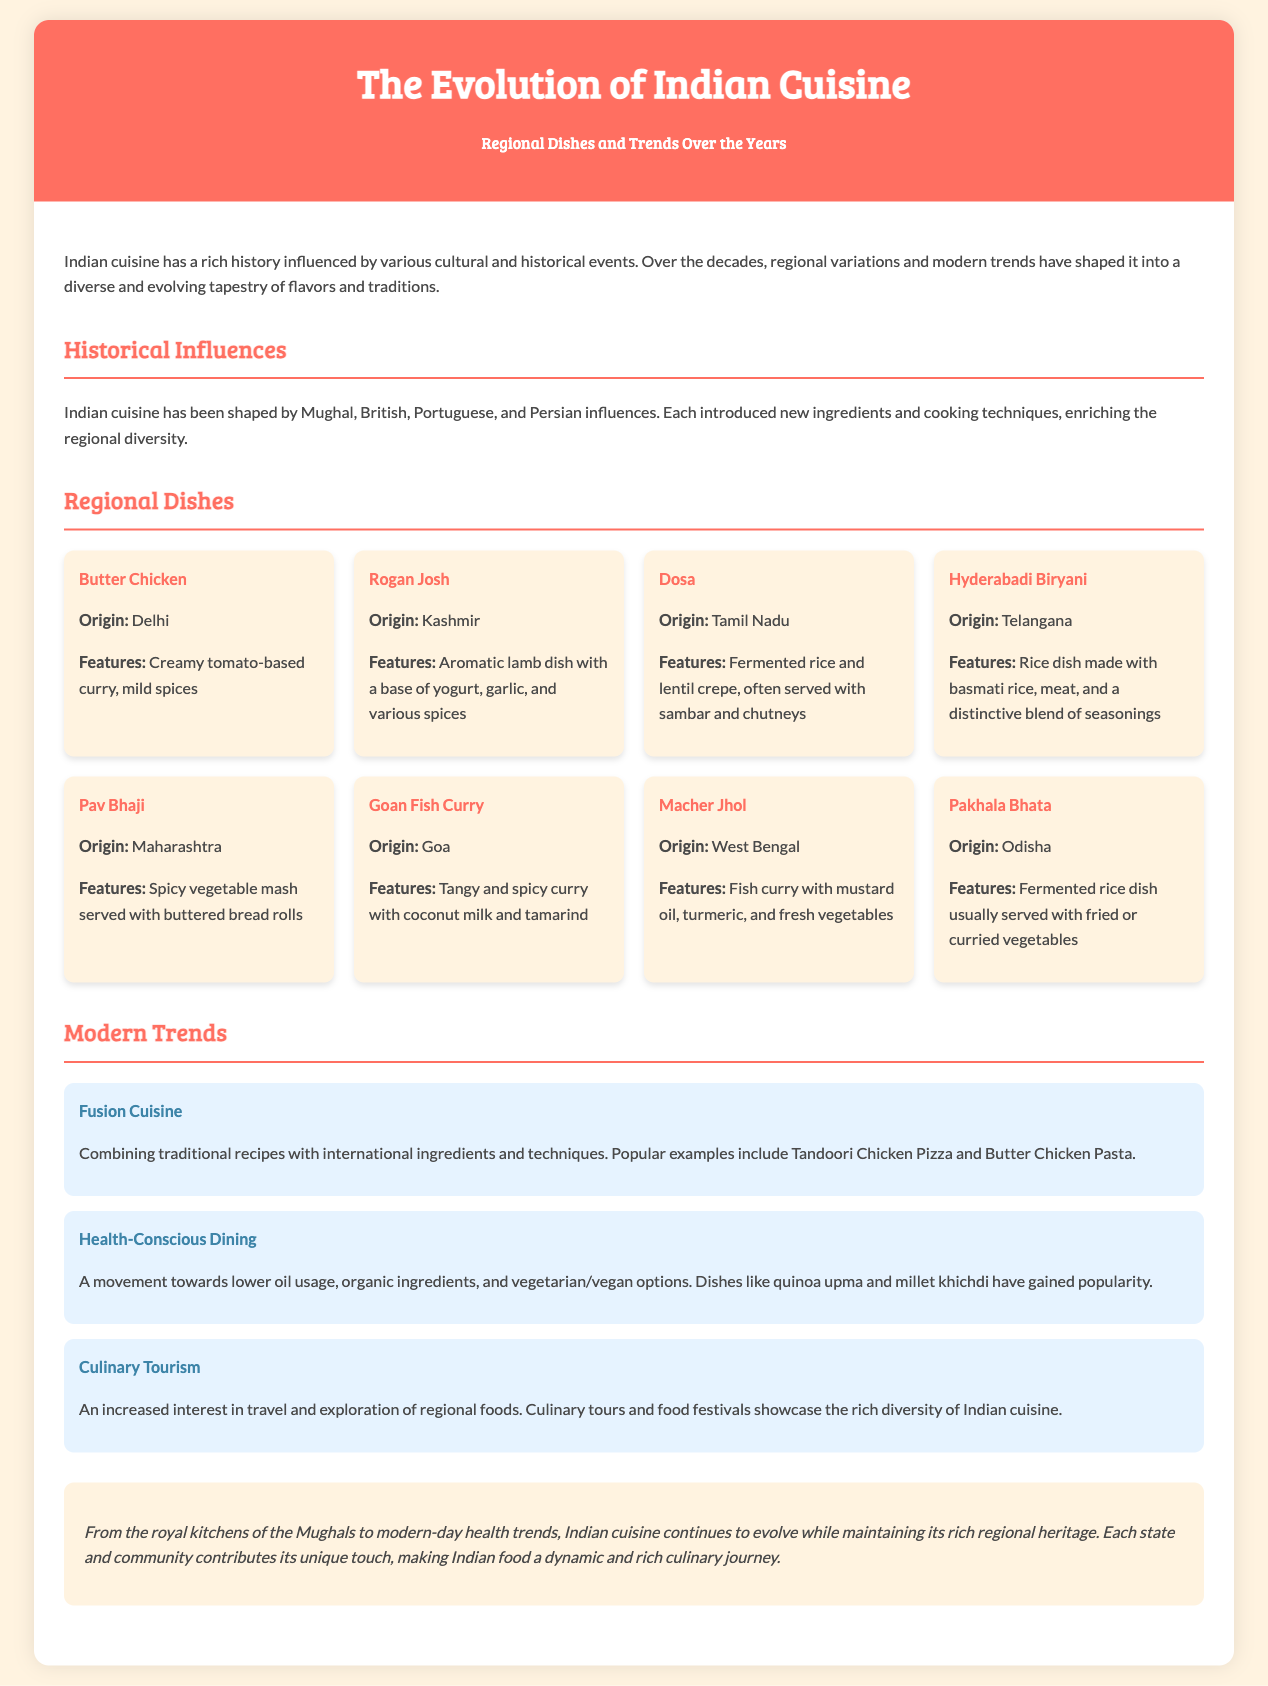what is the title of the document? The title of the document is prominently displayed at the top.
Answer: The Evolution of Indian Cuisine what are the key historical influences on Indian cuisine? The document lists the cultural influences that have shaped Indian cuisine.
Answer: Mughal, British, Portuguese, Persian which dish is associated with Delhi? The dish mentioned in the document that originates from Delhi is highlighted.
Answer: Butter Chicken what type of trend involves combining traditional recipes with international ingredients? This trend is directly mentioned under Modern Trends, indicating a culinary approach.
Answer: Fusion Cuisine which state is known for Dosa? The origin of Dosa is specified in the regional dishes section.
Answer: Tamil Nadu how many modern trends are listed? The document outlines a specific number of trends in modern Indian cuisine.
Answer: Three what flavor profile does Goan Fish Curry feature? The description in the document provides insights about the distinct taste.
Answer: Tangy and spicy which dish from Odisha involves fermented rice? The document describes a specific dish characterized by fermentation.
Answer: Pakhala Bhata what is the conclusion regarding the evolution of Indian cuisine? The final section summarizes the overarching theme of the document.
Answer: It continues to evolve while maintaining its rich regional heritage 